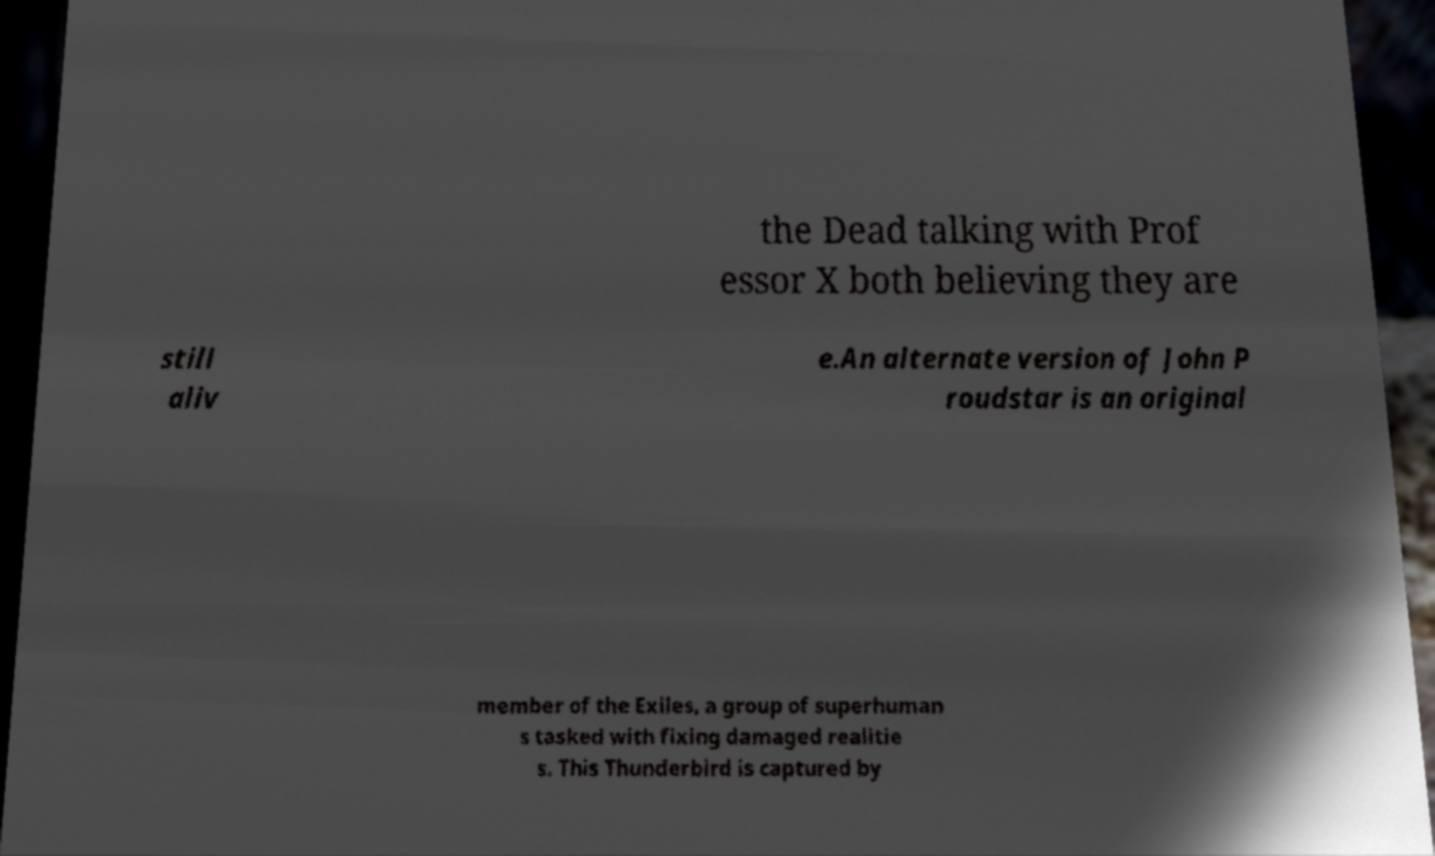Can you accurately transcribe the text from the provided image for me? the Dead talking with Prof essor X both believing they are still aliv e.An alternate version of John P roudstar is an original member of the Exiles, a group of superhuman s tasked with fixing damaged realitie s. This Thunderbird is captured by 